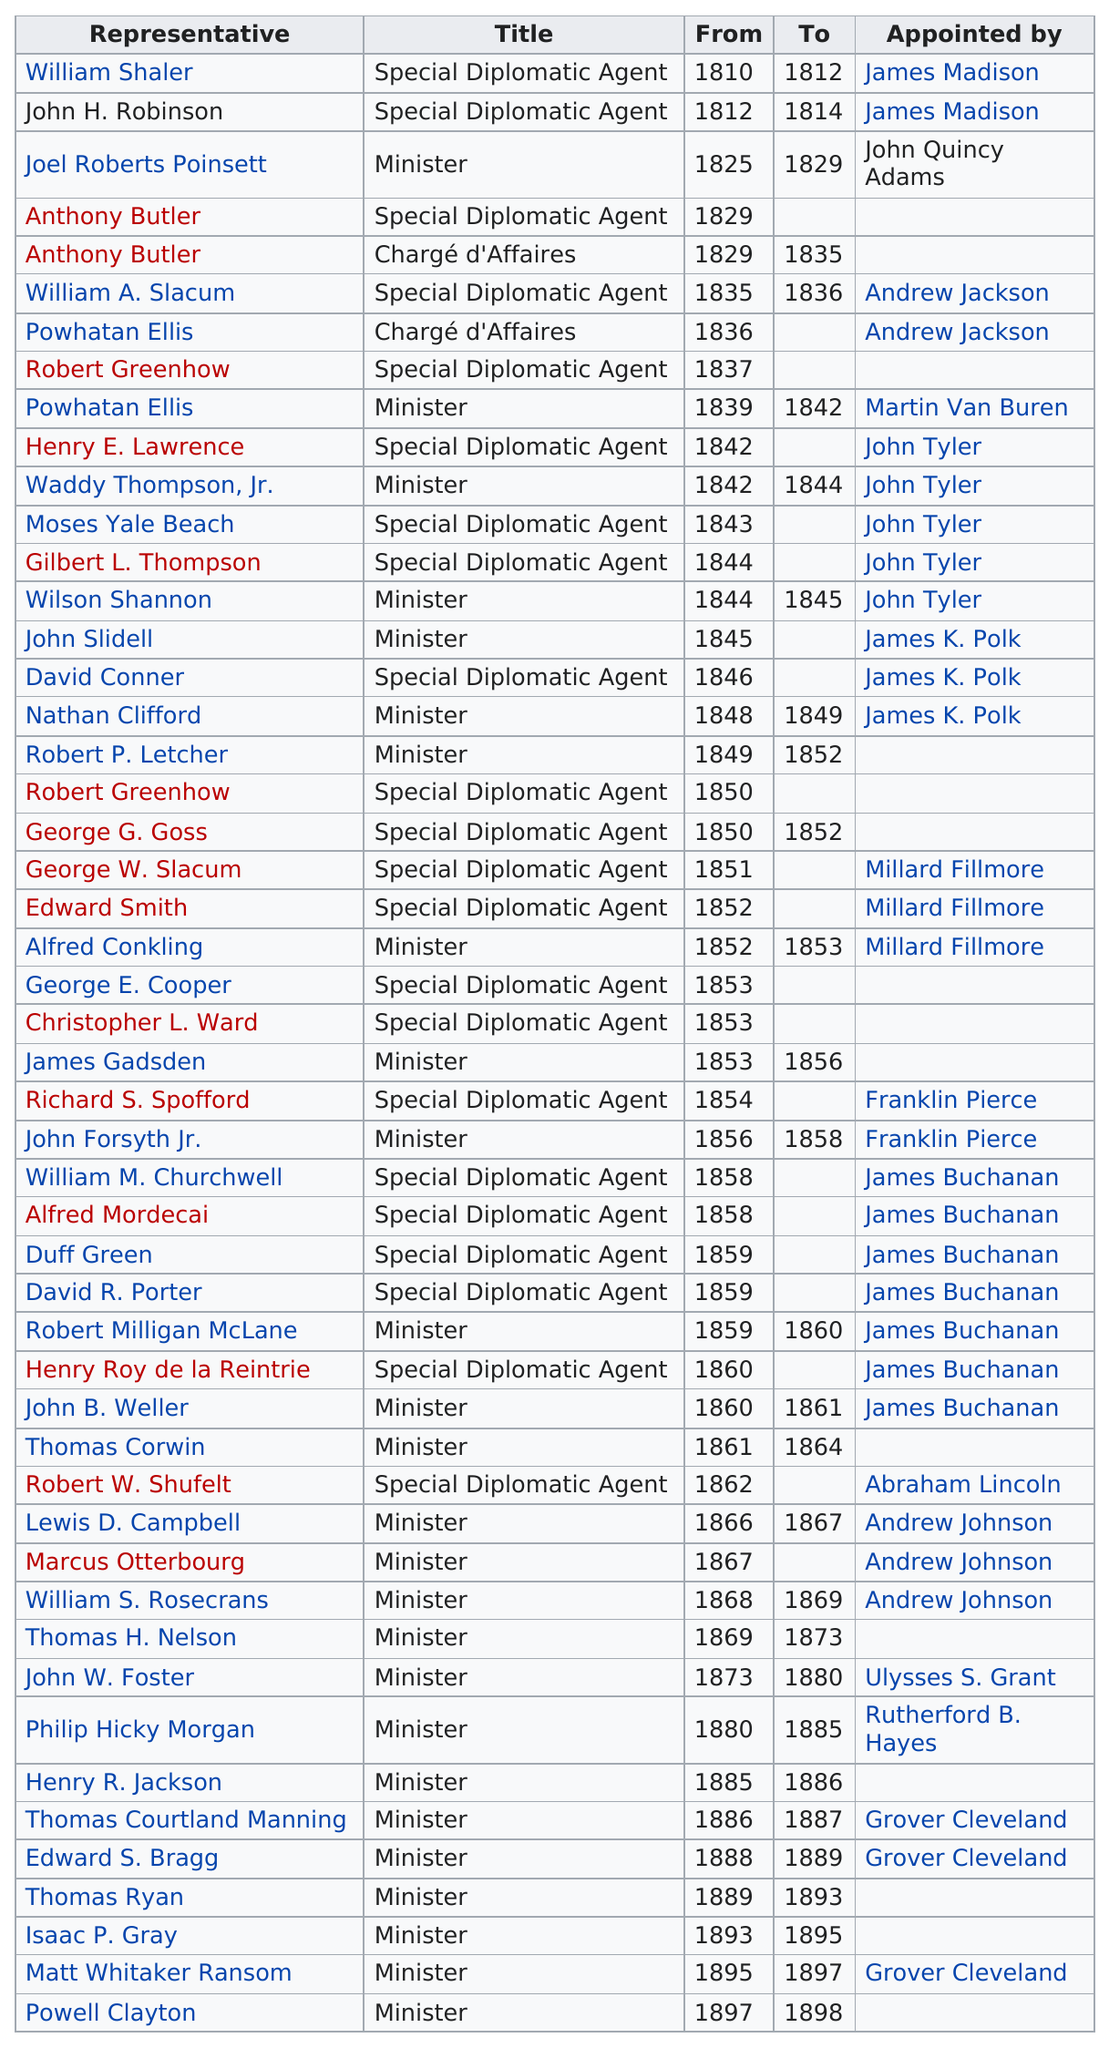Point out several critical features in this image. This table covers a period of 88 years. As of today, the total number of representatives stands at 50. The United States has sent its first ambassador, William Shaler, to Mexico. Powell Clayton was the last person appointed to the table. James Buchanan was the United States President who appointed the most ambassadors to Mexico. 